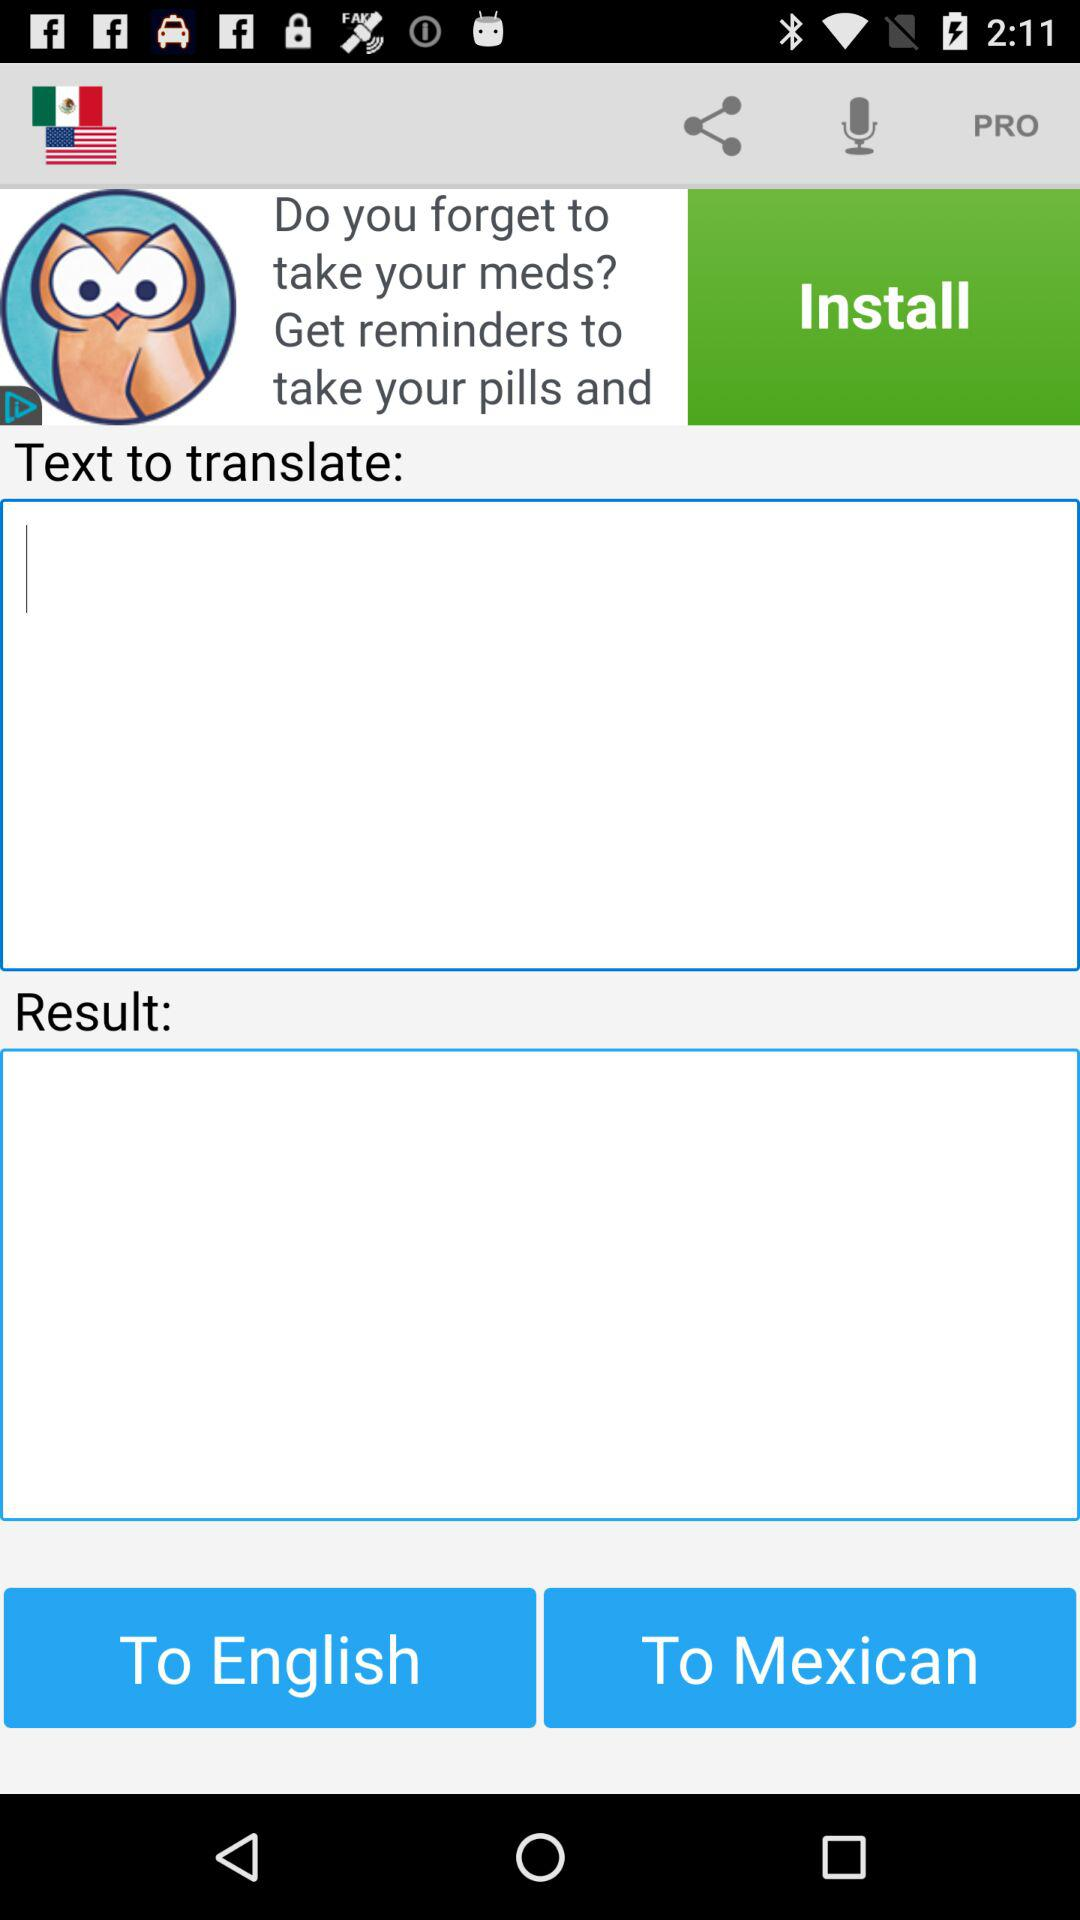What language is translated into what other language? The language is translated from "English" to "Mexican". 